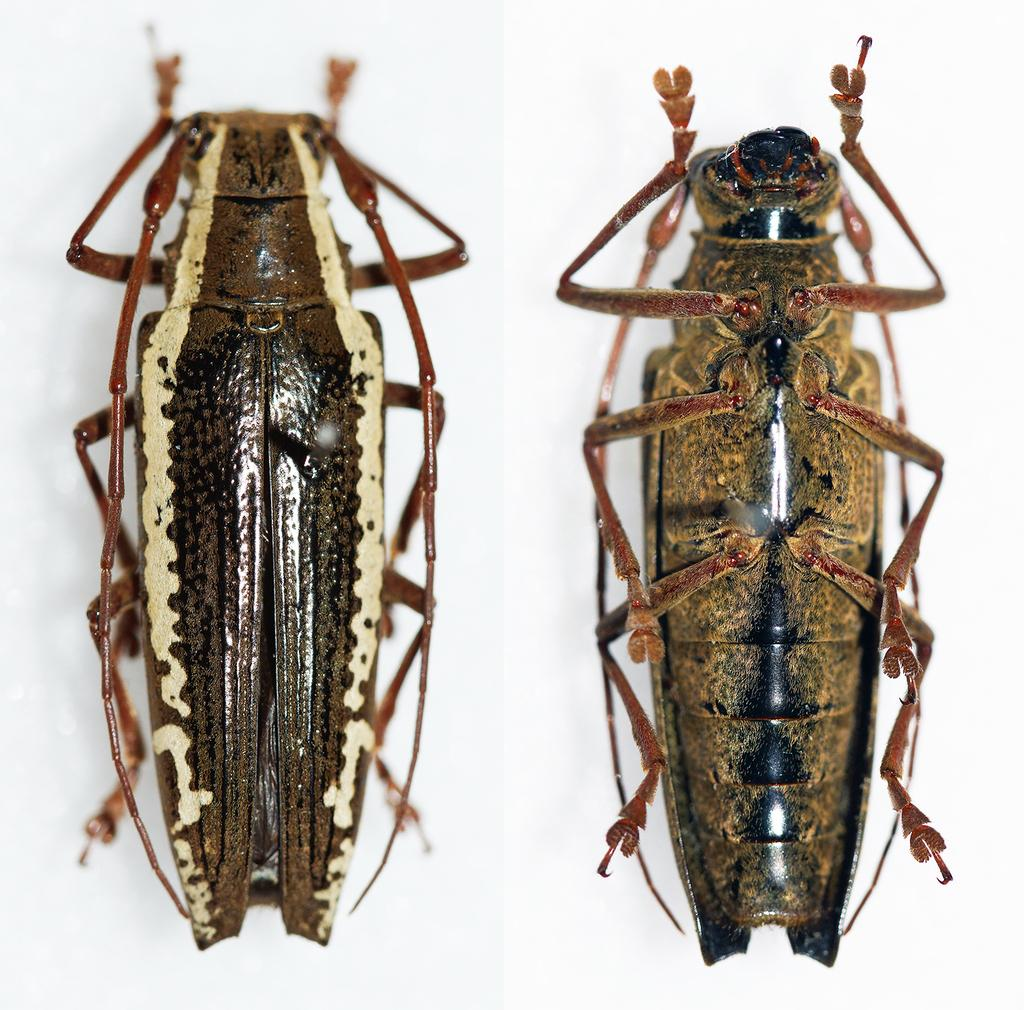What type of insect is in the image? There is a cockroach in the image. How is the cockroach positioned in the image? The upper part of the cockroach's body is on the left side of the image, while the lower part of its body is on the right side. What type of debt is the cockroach trying to pay off in the image? There is no mention of debt in the image, as it features a cockroach with no apparent financial concerns. 